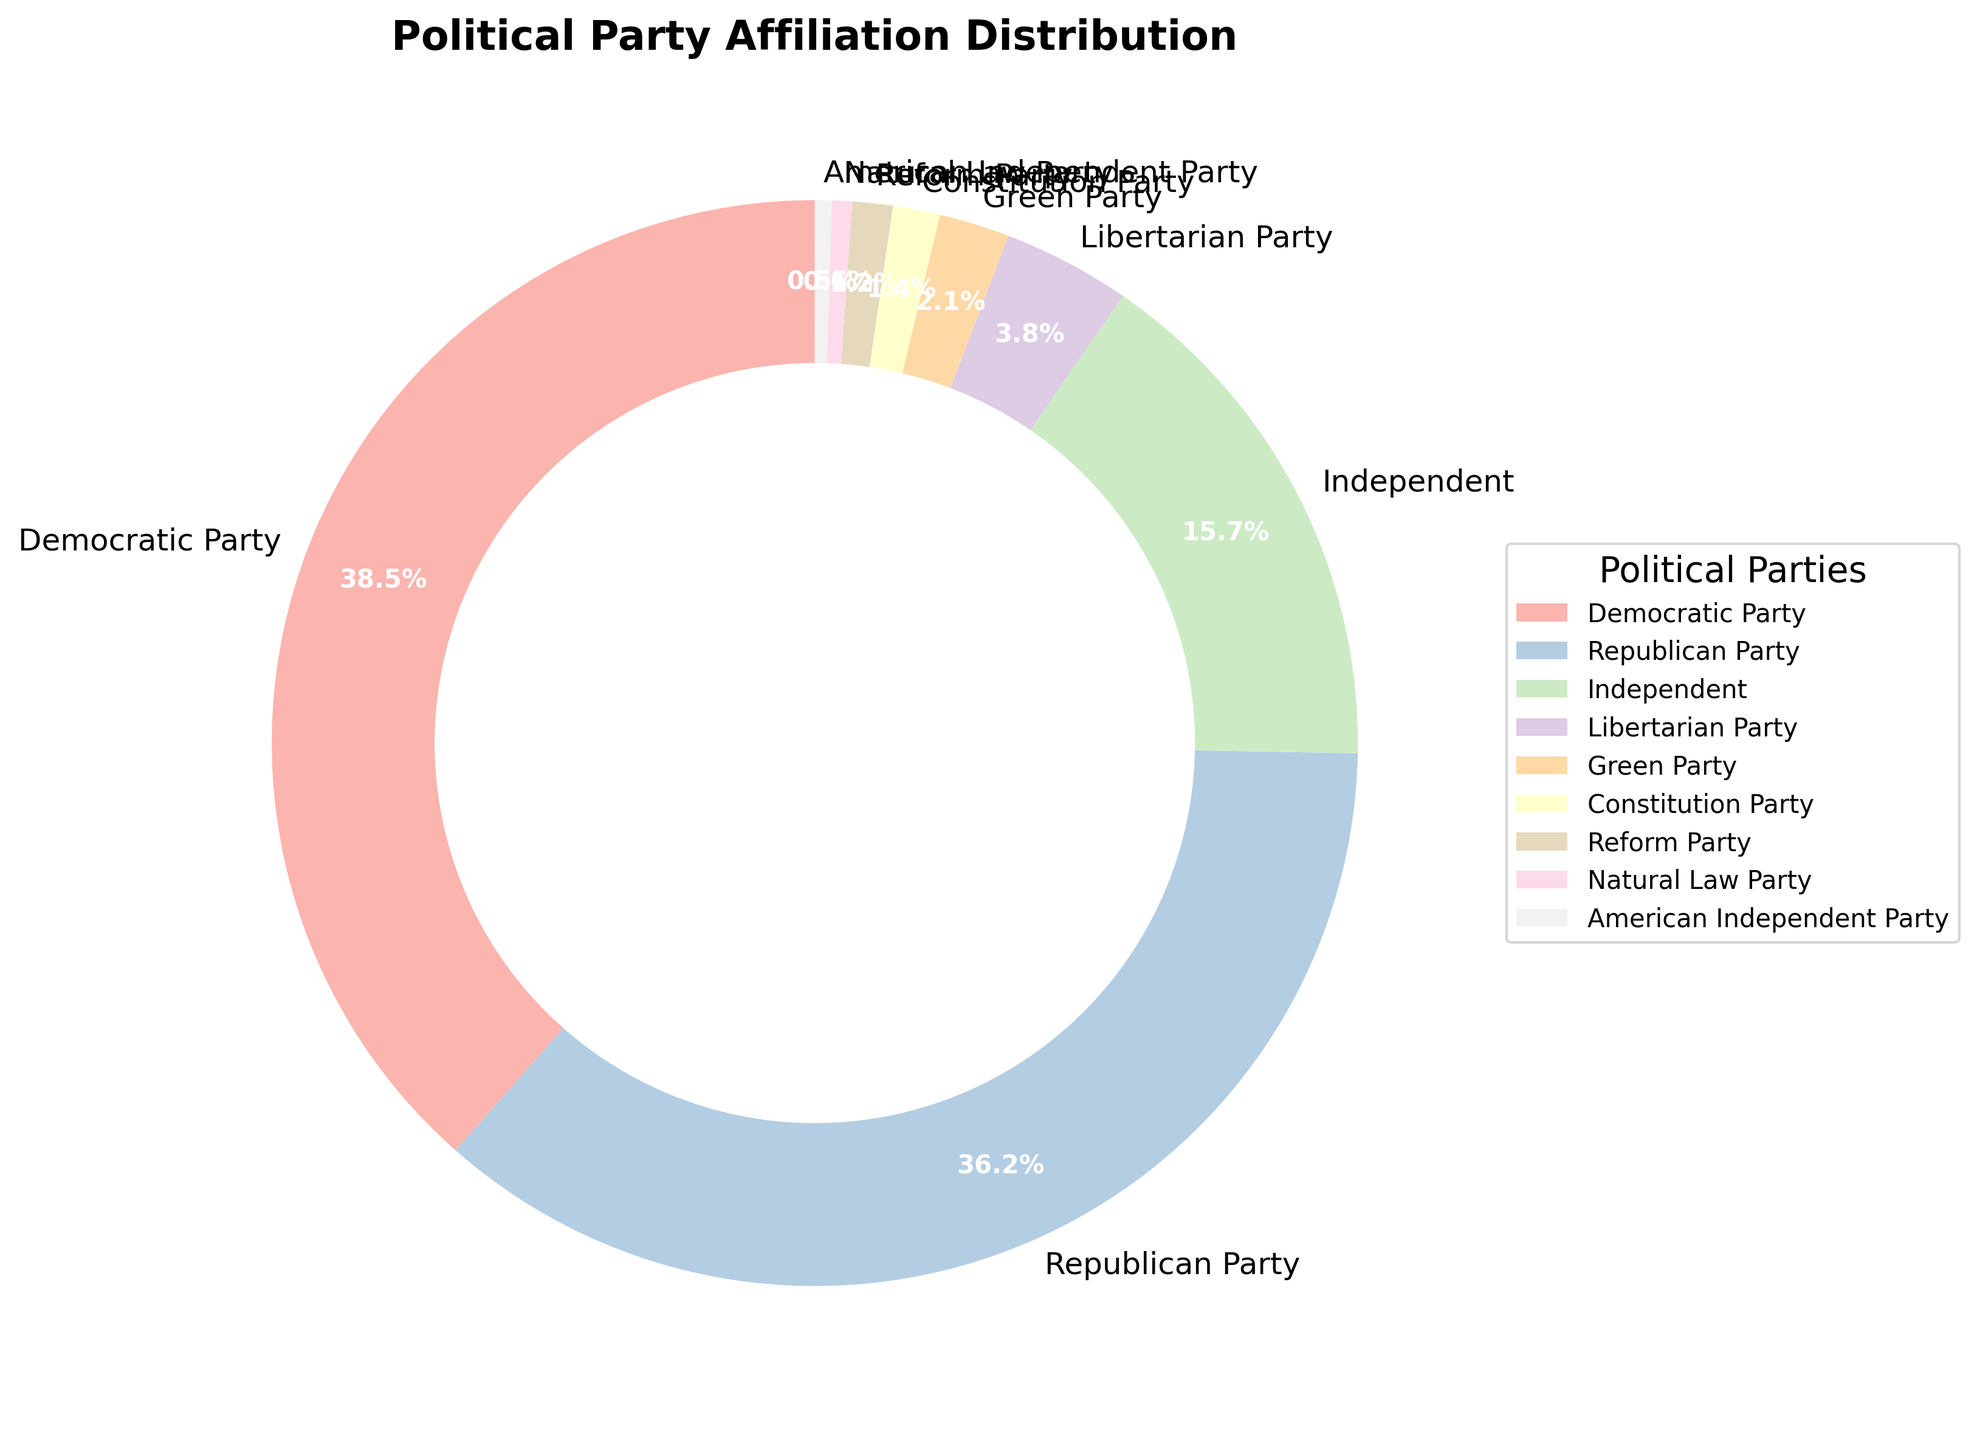What percentage of the electorate did not affiliate with the Democratic Party or Republican Party? To find the percentage of the electorate not affiliated with the Democratic or Republican Parties, sum the percentages of all other parties: 15.7 (Independent) + 3.8 (Libertarian) + 2.1 (Green) + 1.4 (Constitution) + 1.2 (Reform) + 0.6 (Natural Law) + 0.5 (American Independent) = 25.3
Answer: 25.3% Which party has the largest share, and what is its percentage? The figure shows each party's name and its percentage. The Democratic Party has the largest share at 38.5%.
Answer: Democratic Party, 38.5% How does the percentage of Independents compare to that of the Libertarian Party? The percentage of Independents is 15.7%, while that of the Libertarian Party is 3.8%. 15.7% is greater than 3.8%.
Answer: Independents have a higher percentage Which parties have a share less than 2%? The parties with shares less than 2% are the Constitution Party (1.4%), Reform Party (1.2%), Natural Law Party (0.6%), and American Independent Party (0.5%).
Answer: Constitution, Reform, Natural Law, American Independent What is the combined percentage of the Green Party and Reform Party? Sum the percentages of the Green Party and Reform Party: 2.1% (Green) + 1.2% (Reform) = 3.3%.
Answer: 3.3% How much larger is the Democratic Party's share compared to the Republican Party's share? Subtract the Republican Party's percentage from the Democratic Party's percentage: 38.5% - 36.2% = 2.3%.
Answer: 2.3% What are the two smallest parties, and what are their percentages? The two smallest parties are the Natural Law Party (0.6%) and the American Independent Party (0.5%).
Answer: Natural Law Party, 0.6%; American Independent Party, 0.5% Does any party have exactly half of the Democratic Party's percentage? Half of the Democratic Party's percentage is 38.5% / 2 = 19.25%. No party matches this percentage.
Answer: No What is the range of percentages shown on the pie chart? The range is found by subtracting the smallest percentage from the largest: 38.5% (Democratic) - 0.5% (American Independent) = 38%.
Answer: 38% What visual feature distinguishes the Democratic Party and the Republican Party from smaller parties on the pie chart? The Democratic and Republican Parties occupy the largest segments of the pie chart, which are visually prominent compared to the smaller, less noticeable segments of the minor parties.
Answer: Larger segments 